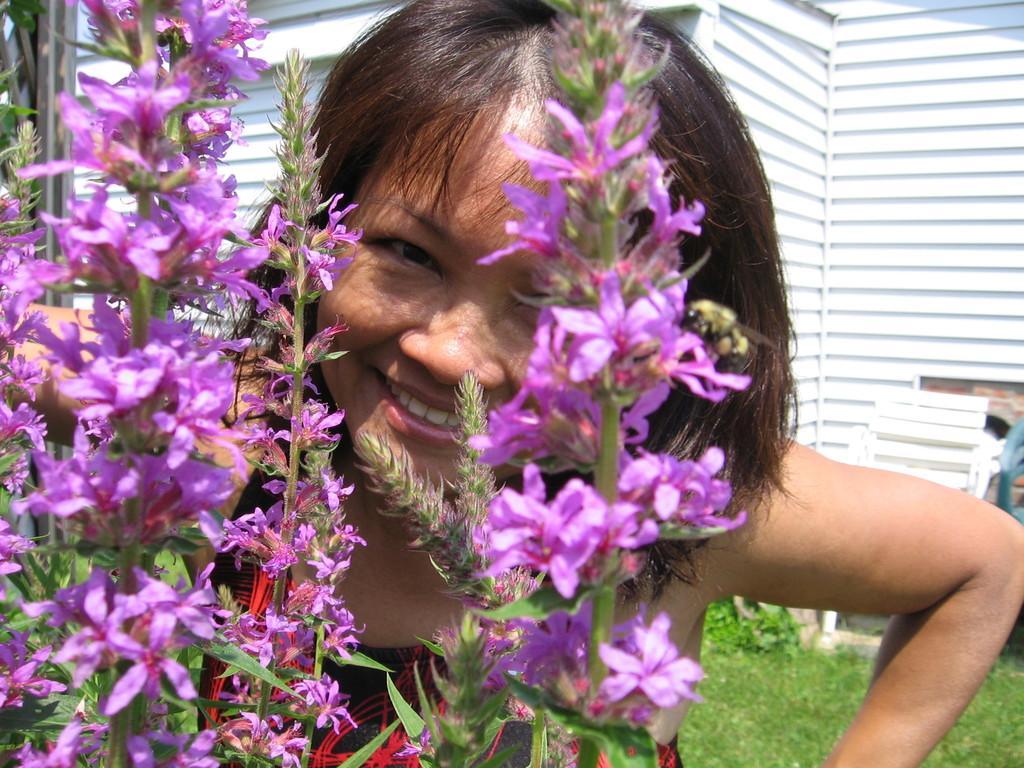In one or two sentences, can you explain what this image depicts? In this picture we can see flowers, grass and a girl smiling and in the background we can see the wall. 